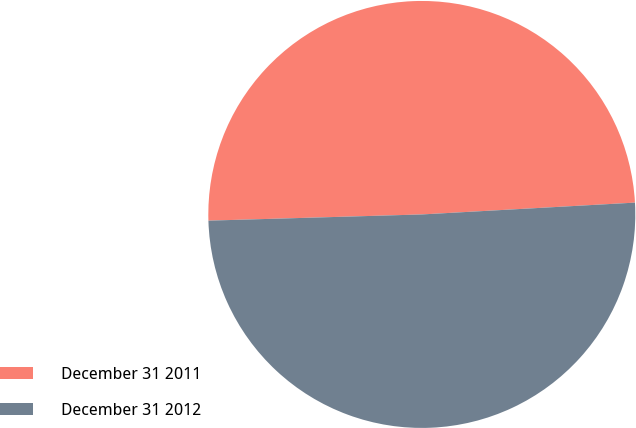<chart> <loc_0><loc_0><loc_500><loc_500><pie_chart><fcel>December 31 2011<fcel>December 31 2012<nl><fcel>49.58%<fcel>50.42%<nl></chart> 